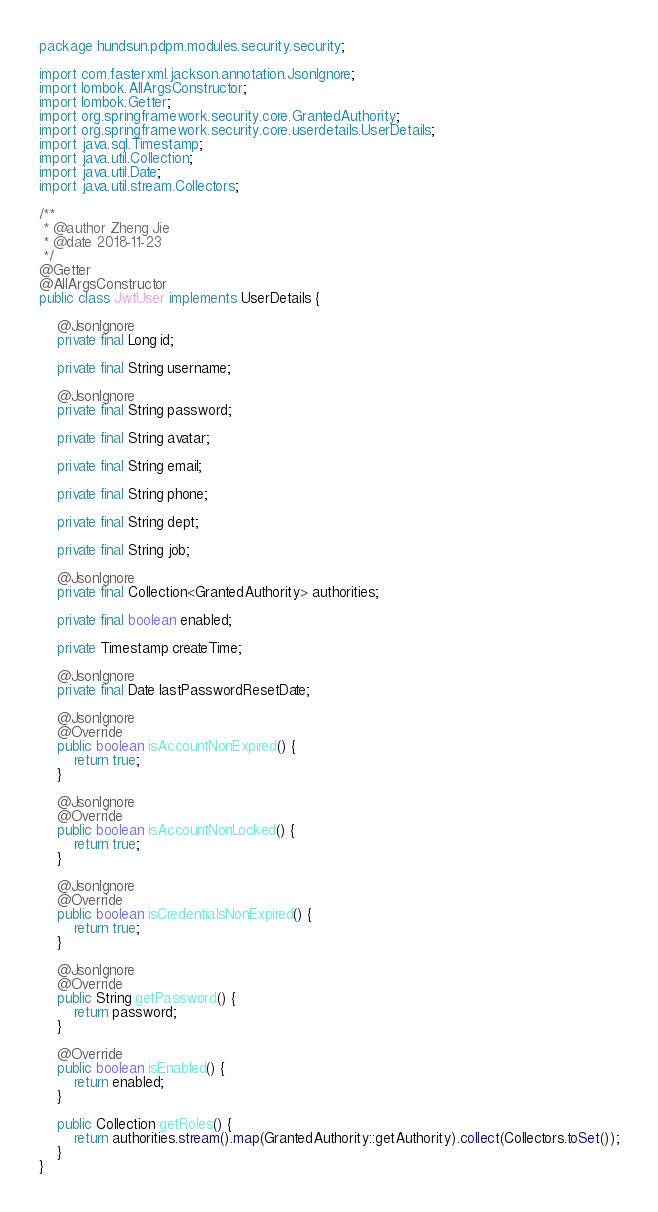Convert code to text. <code><loc_0><loc_0><loc_500><loc_500><_Java_>package hundsun.pdpm.modules.security.security;

import com.fasterxml.jackson.annotation.JsonIgnore;
import lombok.AllArgsConstructor;
import lombok.Getter;
import org.springframework.security.core.GrantedAuthority;
import org.springframework.security.core.userdetails.UserDetails;
import java.sql.Timestamp;
import java.util.Collection;
import java.util.Date;
import java.util.stream.Collectors;

/**
 * @author Zheng Jie
 * @date 2018-11-23
 */
@Getter
@AllArgsConstructor
public class JwtUser implements UserDetails {

    @JsonIgnore
    private final Long id;

    private final String username;

    @JsonIgnore
    private final String password;

    private final String avatar;

    private final String email;

    private final String phone;

    private final String dept;

    private final String job;

    @JsonIgnore
    private final Collection<GrantedAuthority> authorities;

    private final boolean enabled;

    private Timestamp createTime;

    @JsonIgnore
    private final Date lastPasswordResetDate;

    @JsonIgnore
    @Override
    public boolean isAccountNonExpired() {
        return true;
    }

    @JsonIgnore
    @Override
    public boolean isAccountNonLocked() {
        return true;
    }

    @JsonIgnore
    @Override
    public boolean isCredentialsNonExpired() {
        return true;
    }

    @JsonIgnore
    @Override
    public String getPassword() {
        return password;
    }

    @Override
    public boolean isEnabled() {
        return enabled;
    }

    public Collection getRoles() {
        return authorities.stream().map(GrantedAuthority::getAuthority).collect(Collectors.toSet());
    }
}
</code> 